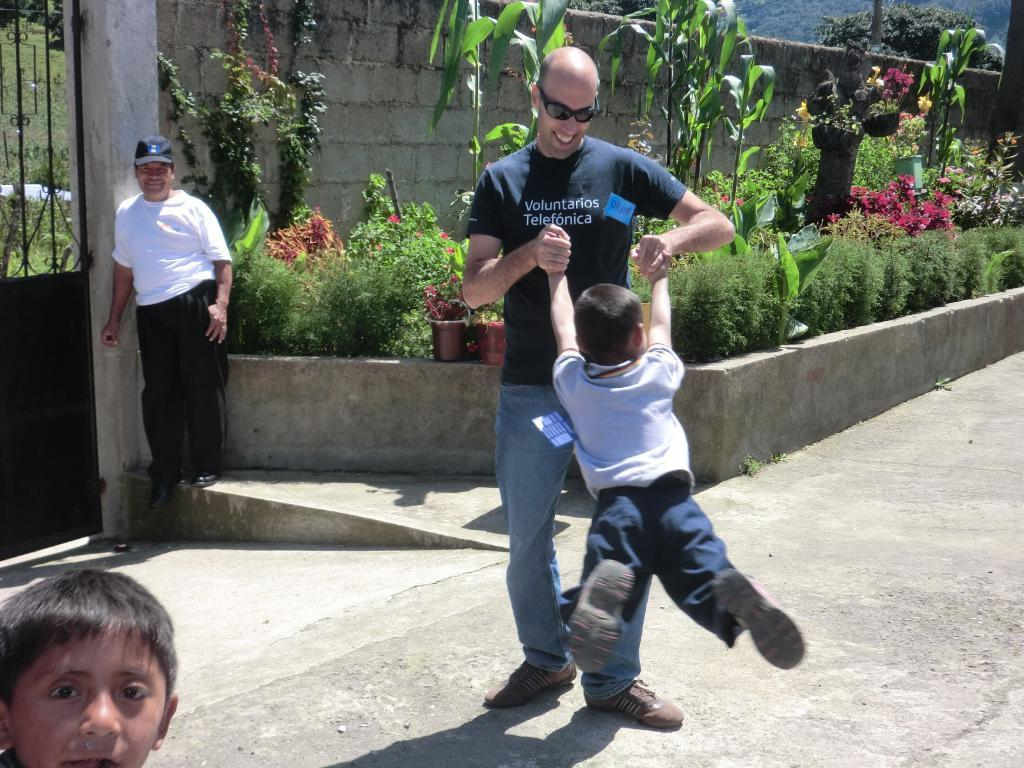Who is present in the image? There is a man and a kid in the image. What are the man and kid doing in the image? The man and kid are playing in the image. What can be seen in the background of the image? There are many plants and trees in the image, which are inside a fence. Where is the entrance to the fenced area? There is a gate on the left side of the image. How does the snake increase the channel's viewership in the image? There is no snake or channel present in the image, so this question cannot be answered. 